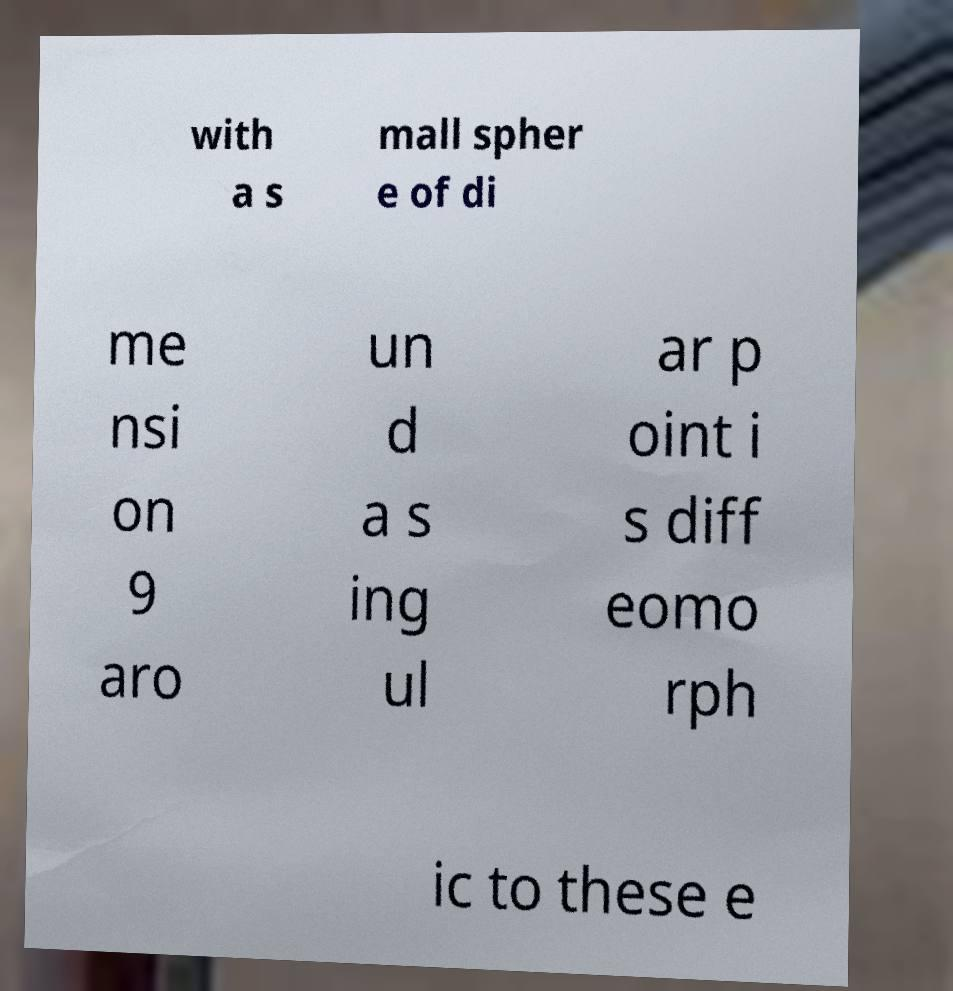Could you assist in decoding the text presented in this image and type it out clearly? with a s mall spher e of di me nsi on 9 aro un d a s ing ul ar p oint i s diff eomo rph ic to these e 